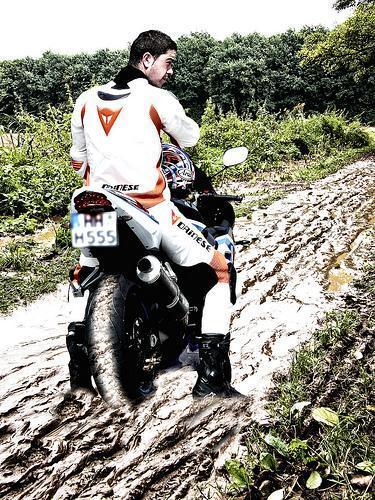How many people are pictured?
Give a very brief answer. 1. 